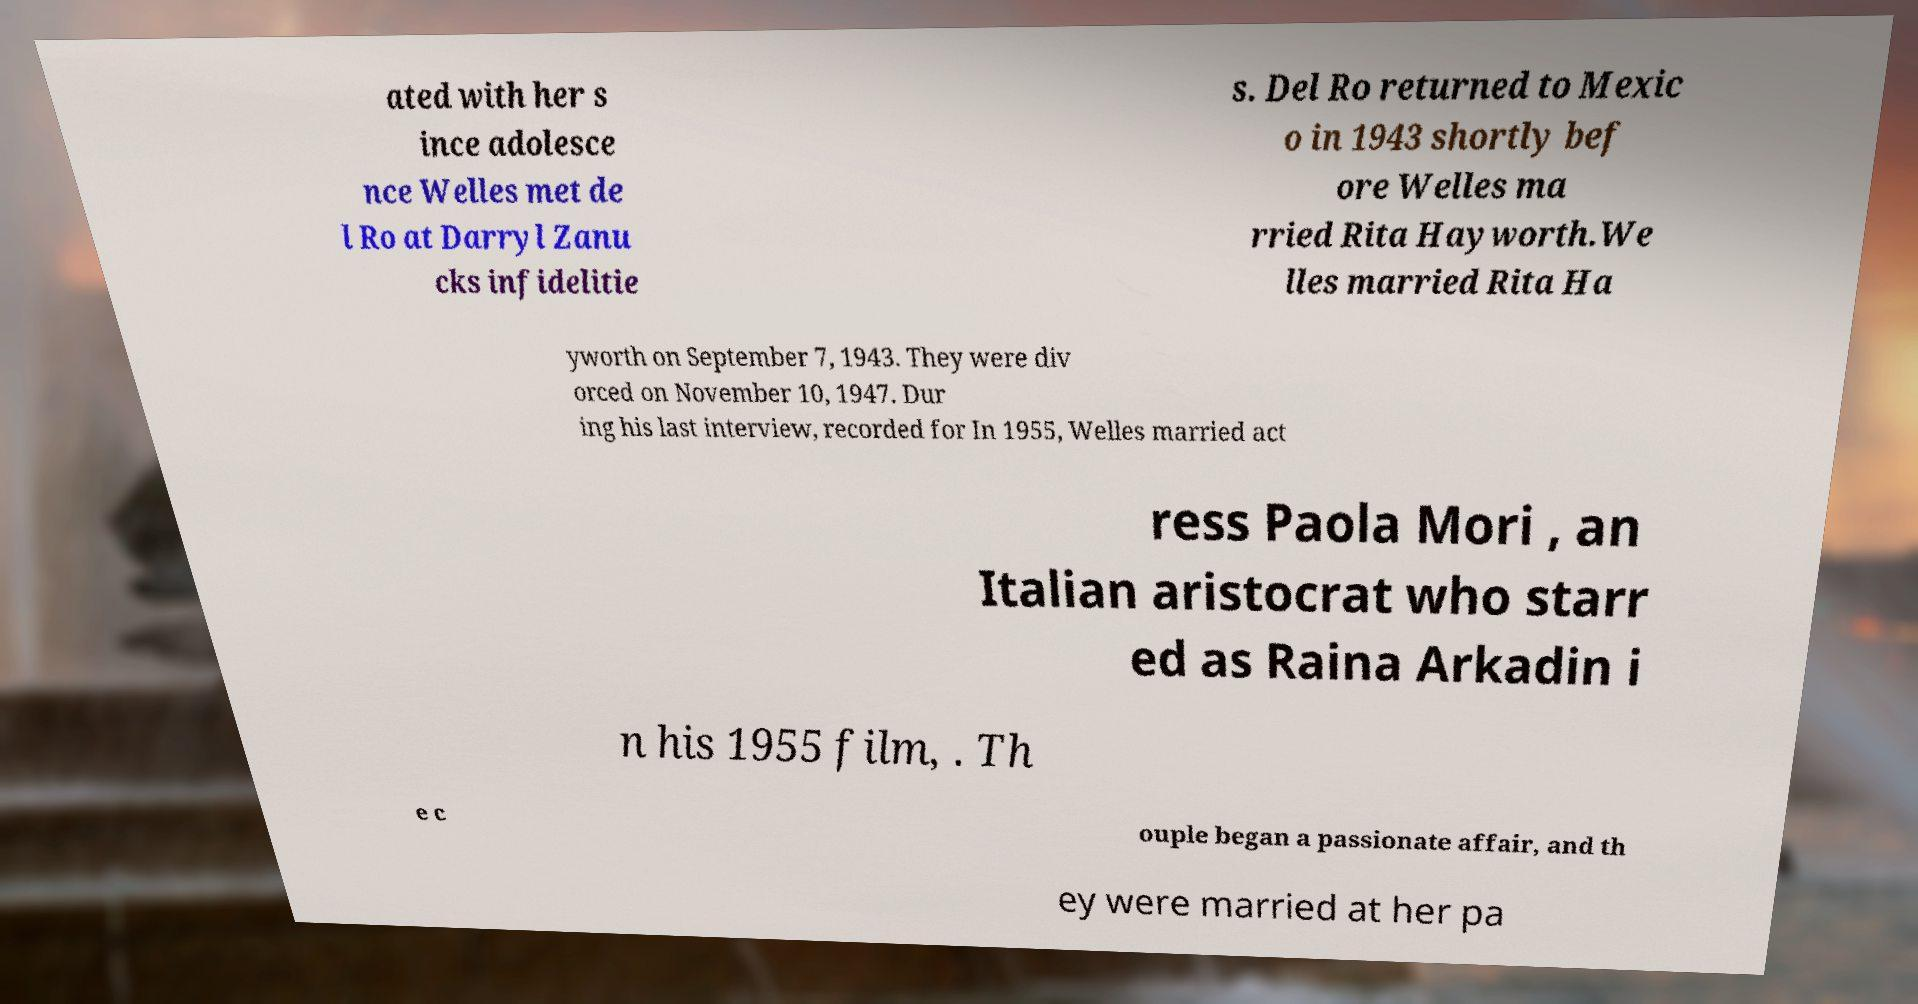Can you accurately transcribe the text from the provided image for me? ated with her s ince adolesce nce Welles met de l Ro at Darryl Zanu cks infidelitie s. Del Ro returned to Mexic o in 1943 shortly bef ore Welles ma rried Rita Hayworth.We lles married Rita Ha yworth on September 7, 1943. They were div orced on November 10, 1947. Dur ing his last interview, recorded for In 1955, Welles married act ress Paola Mori , an Italian aristocrat who starr ed as Raina Arkadin i n his 1955 film, . Th e c ouple began a passionate affair, and th ey were married at her pa 